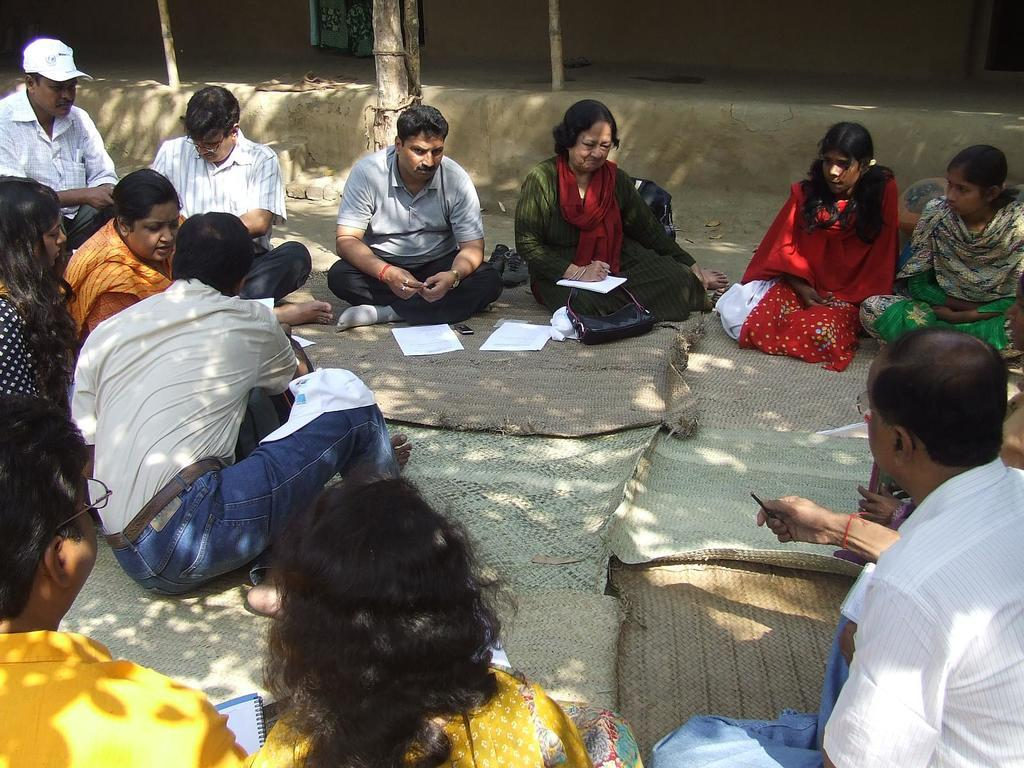How many people are in the image? There is a group of people in the image. What is the arrangement of the people in the image? The people are sitting in a round formation on the ground. What can be seen in the background of the image? There is a wall in the background of the image. What type of cap is being worn by the person sitting in the square formation in the image? There is no square formation in the image, and no one is wearing a cap. 